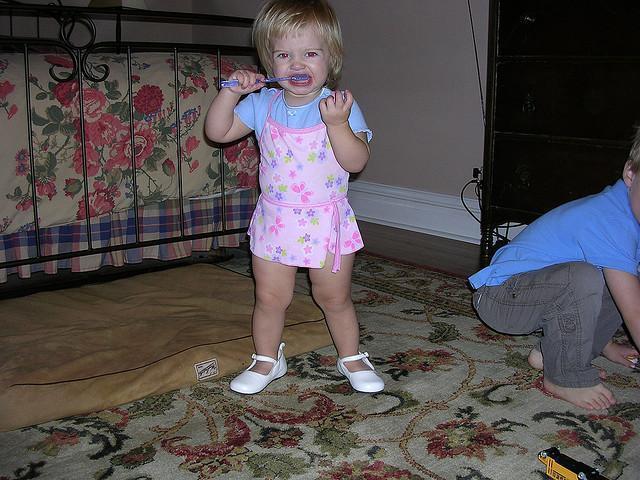Why are her eyes red?
Select the accurate answer and provide explanation: 'Answer: answer
Rationale: rationale.'
Options: Camera filter, reflected light, birth defect, contact lenses. Answer: reflected light.
Rationale: Sometimes when you take a picture the glare will make your eyes red. 